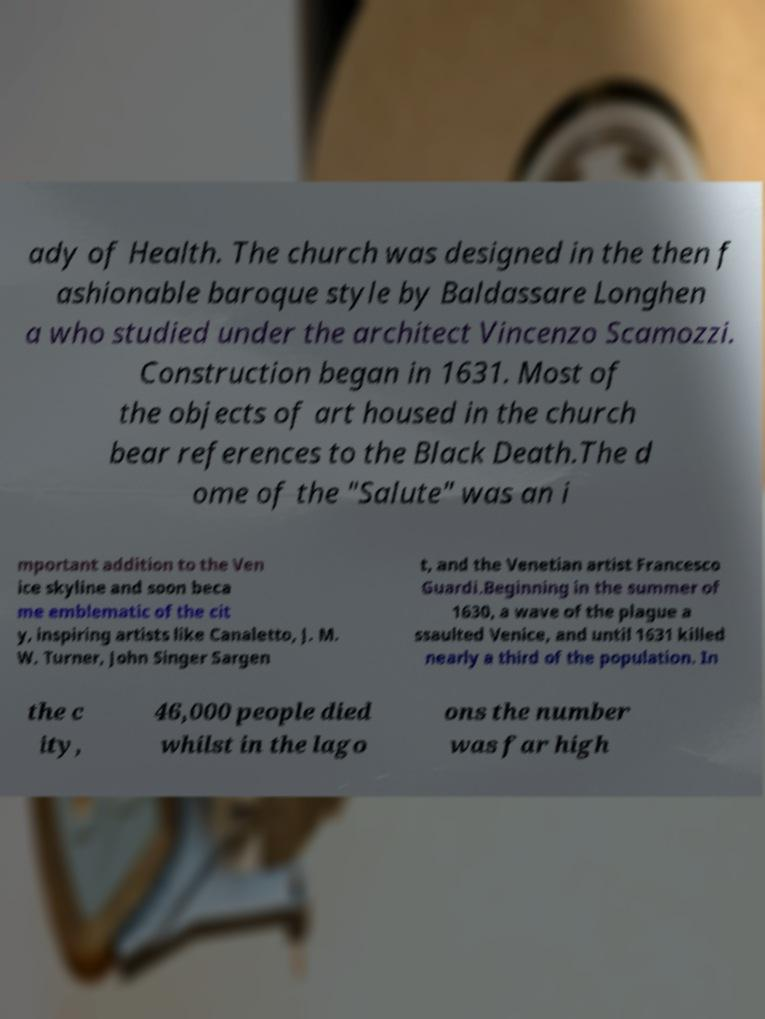I need the written content from this picture converted into text. Can you do that? ady of Health. The church was designed in the then f ashionable baroque style by Baldassare Longhen a who studied under the architect Vincenzo Scamozzi. Construction began in 1631. Most of the objects of art housed in the church bear references to the Black Death.The d ome of the "Salute" was an i mportant addition to the Ven ice skyline and soon beca me emblematic of the cit y, inspiring artists like Canaletto, J. M. W. Turner, John Singer Sargen t, and the Venetian artist Francesco Guardi.Beginning in the summer of 1630, a wave of the plague a ssaulted Venice, and until 1631 killed nearly a third of the population. In the c ity, 46,000 people died whilst in the lago ons the number was far high 